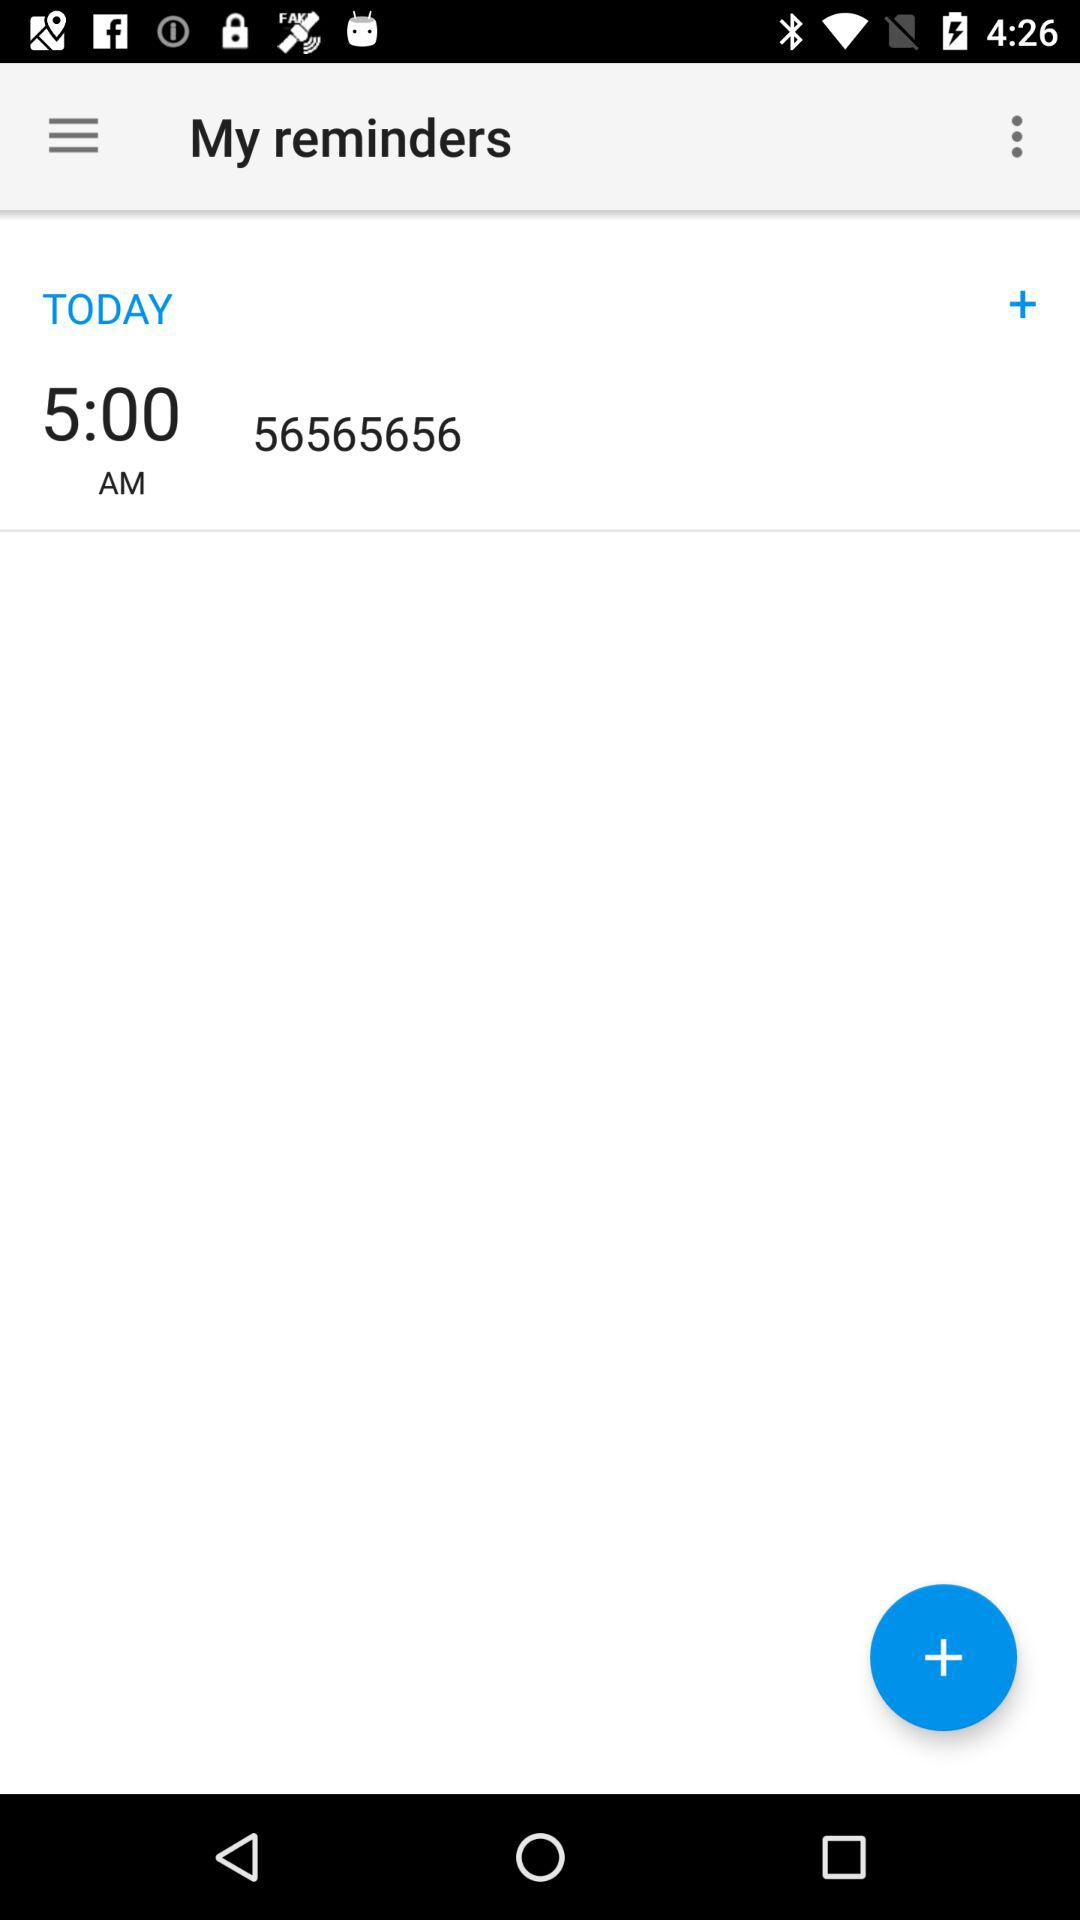What is the phone number associated with this reminder?
Answer the question using a single word or phrase. 56565656 